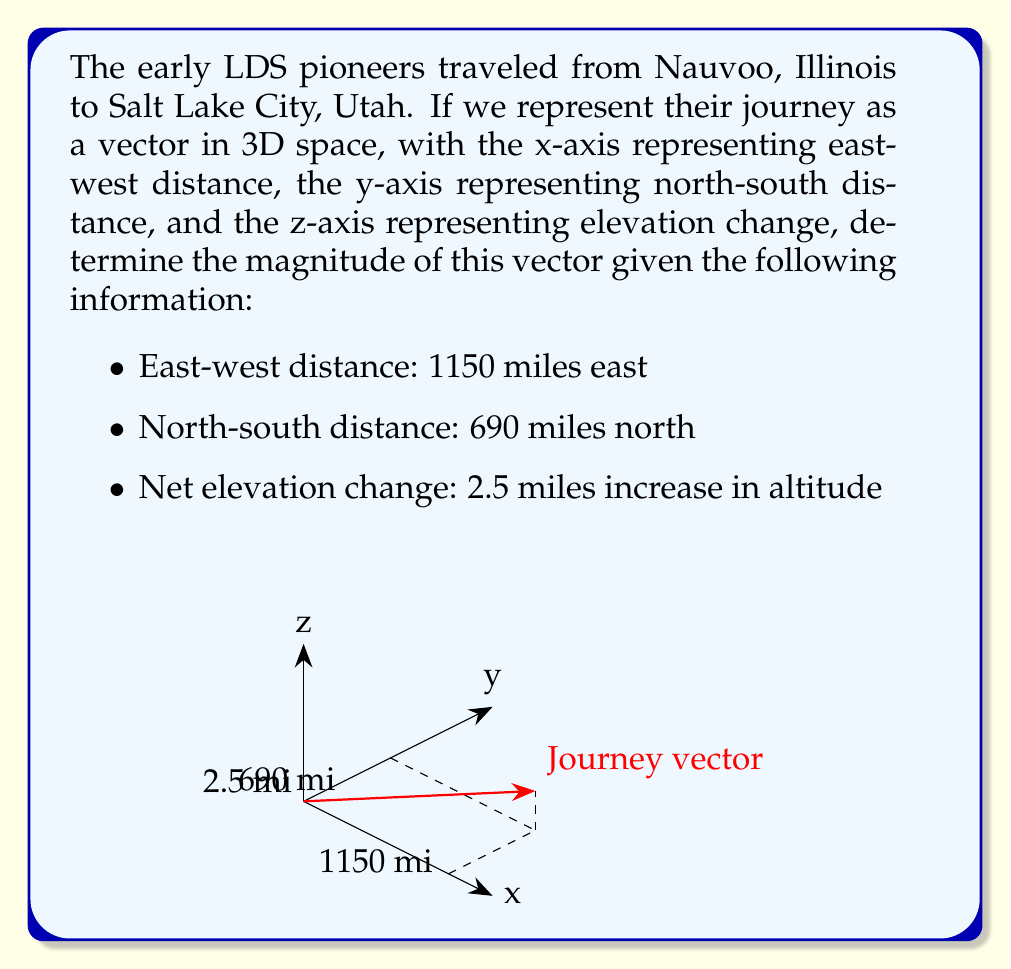Give your solution to this math problem. To solve this problem, we'll use the vector magnitude formula in 3D space. The magnitude of a vector $\mathbf{v} = (x, y, z)$ is given by:

$$|\mathbf{v}| = \sqrt{x^2 + y^2 + z^2}$$

Let's break down the steps:

1) First, we need to identify our vector components:
   $x = -1150$ (negative because it's eastward)
   $y = 690$
   $z = 2.5$

2) Now, let's substitute these values into the magnitude formula:

   $$|\mathbf{v}| = \sqrt{(-1150)^2 + 690^2 + 2.5^2}$$

3) Simplify the squares:

   $$|\mathbf{v}| = \sqrt{1,322,500 + 476,100 + 6.25}$$

4) Add the terms under the square root:

   $$|\mathbf{v}| = \sqrt{1,798,606.25}$$

5) Calculate the square root:

   $$|\mathbf{v}| \approx 1,341.12$$

Therefore, the magnitude of the vector representing the pioneers' journey is approximately 1,341.12 miles.

This represents the straight-line distance between Nauvoo and Salt Lake City, accounting for both horizontal distance and elevation change. Of course, the actual path taken by the pioneers was longer due to the necessity of following passable routes.
Answer: $1,341.12$ miles 